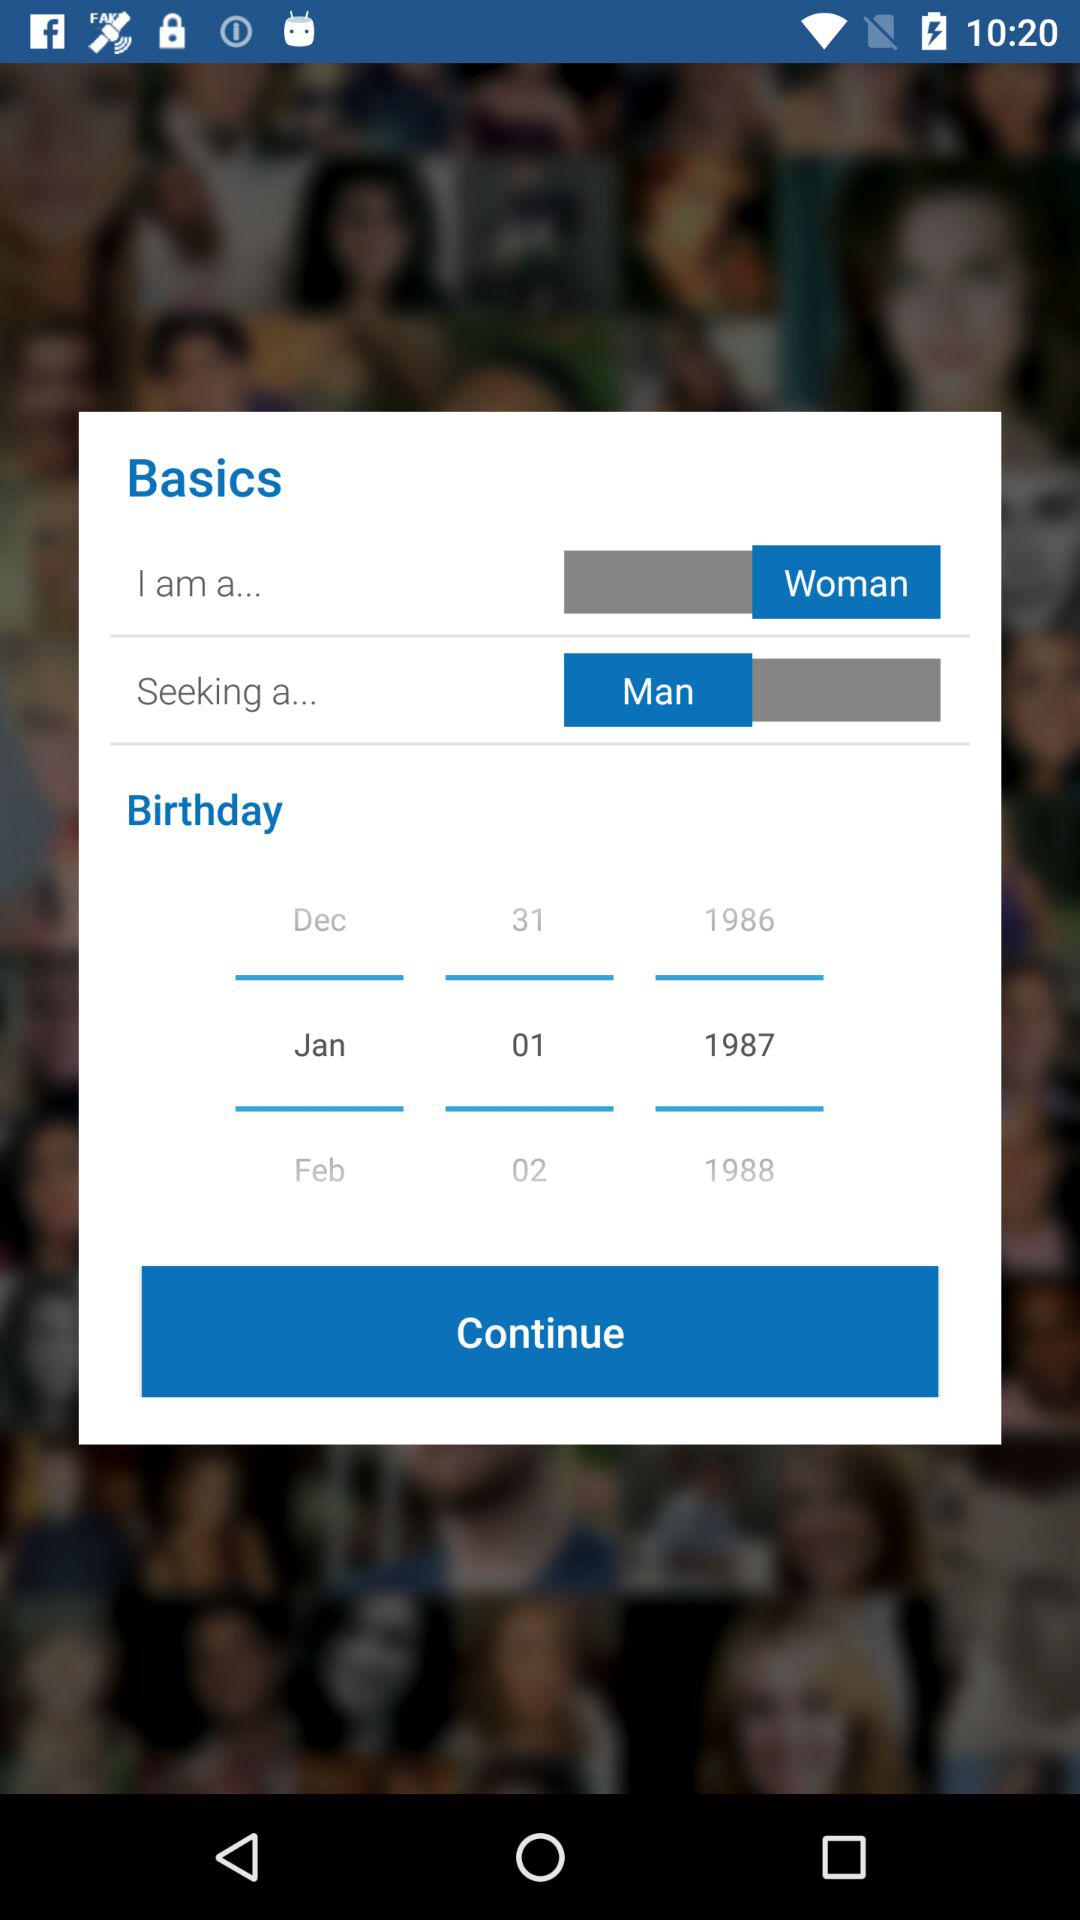What is the selected birthday date? The selected birthday date is January 1, 1987. 